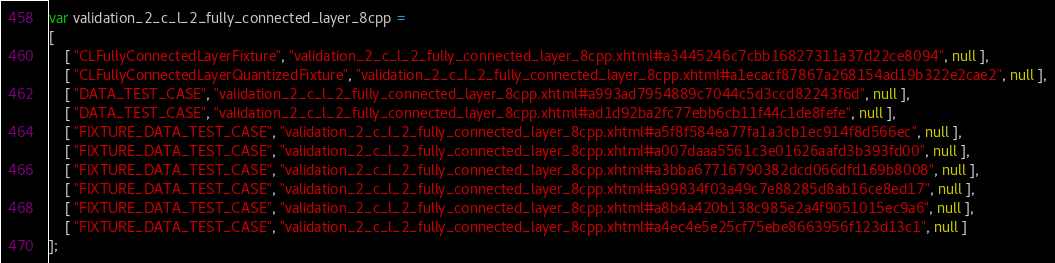<code> <loc_0><loc_0><loc_500><loc_500><_JavaScript_>var validation_2_c_l_2_fully_connected_layer_8cpp =
[
    [ "CLFullyConnectedLayerFixture", "validation_2_c_l_2_fully_connected_layer_8cpp.xhtml#a3445246c7cbb16827311a37d22ce8094", null ],
    [ "CLFullyConnectedLayerQuantizedFixture", "validation_2_c_l_2_fully_connected_layer_8cpp.xhtml#a1ecacf87867a268154ad19b322e2cae2", null ],
    [ "DATA_TEST_CASE", "validation_2_c_l_2_fully_connected_layer_8cpp.xhtml#a993ad7954889c7044c5d3ccd82243f6d", null ],
    [ "DATA_TEST_CASE", "validation_2_c_l_2_fully_connected_layer_8cpp.xhtml#ad1d92ba2fc77ebb6cb11f44c1de8fefe", null ],
    [ "FIXTURE_DATA_TEST_CASE", "validation_2_c_l_2_fully_connected_layer_8cpp.xhtml#a5f8f584ea77fa1a3cb1ec914f8d566ec", null ],
    [ "FIXTURE_DATA_TEST_CASE", "validation_2_c_l_2_fully_connected_layer_8cpp.xhtml#a007daaa5561c3e01626aafd3b393fd00", null ],
    [ "FIXTURE_DATA_TEST_CASE", "validation_2_c_l_2_fully_connected_layer_8cpp.xhtml#a3bba67716790382dcd066dfd169b8008", null ],
    [ "FIXTURE_DATA_TEST_CASE", "validation_2_c_l_2_fully_connected_layer_8cpp.xhtml#a99834f03a49c7e88285d8ab16ce8ed17", null ],
    [ "FIXTURE_DATA_TEST_CASE", "validation_2_c_l_2_fully_connected_layer_8cpp.xhtml#a8b4a420b138c985e2a4f9051015ec9a6", null ],
    [ "FIXTURE_DATA_TEST_CASE", "validation_2_c_l_2_fully_connected_layer_8cpp.xhtml#a4ec4e5e25cf75ebe8663956f123d13c1", null ]
];</code> 